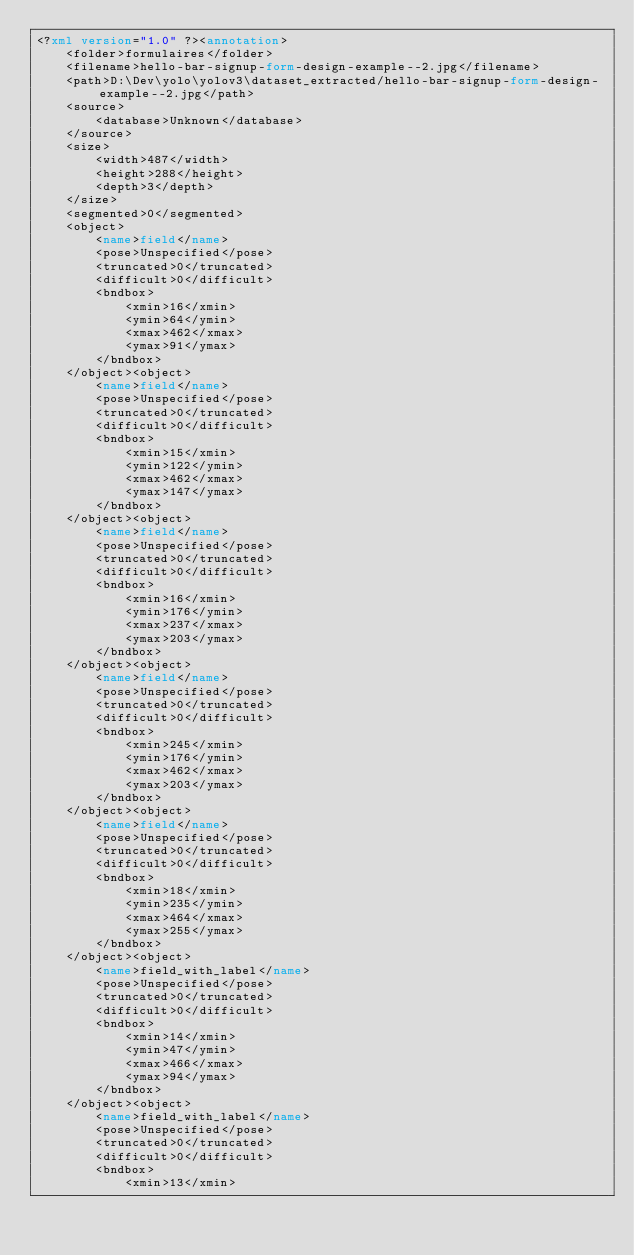<code> <loc_0><loc_0><loc_500><loc_500><_XML_><?xml version="1.0" ?><annotation>
    <folder>formulaires</folder>
    <filename>hello-bar-signup-form-design-example--2.jpg</filename>
    <path>D:\Dev\yolo\yolov3\dataset_extracted/hello-bar-signup-form-design-example--2.jpg</path>
    <source>
        <database>Unknown</database>
    </source>
    <size>
        <width>487</width>
        <height>288</height>
        <depth>3</depth>
    </size>
    <segmented>0</segmented>
    <object>
        <name>field</name>
        <pose>Unspecified</pose>
        <truncated>0</truncated>
        <difficult>0</difficult>
        <bndbox>
            <xmin>16</xmin>
            <ymin>64</ymin>
            <xmax>462</xmax>
            <ymax>91</ymax>
        </bndbox>
    </object><object>
        <name>field</name>
        <pose>Unspecified</pose>
        <truncated>0</truncated>
        <difficult>0</difficult>
        <bndbox>
            <xmin>15</xmin>
            <ymin>122</ymin>
            <xmax>462</xmax>
            <ymax>147</ymax>
        </bndbox>
    </object><object>
        <name>field</name>
        <pose>Unspecified</pose>
        <truncated>0</truncated>
        <difficult>0</difficult>
        <bndbox>
            <xmin>16</xmin>
            <ymin>176</ymin>
            <xmax>237</xmax>
            <ymax>203</ymax>
        </bndbox>
    </object><object>
        <name>field</name>
        <pose>Unspecified</pose>
        <truncated>0</truncated>
        <difficult>0</difficult>
        <bndbox>
            <xmin>245</xmin>
            <ymin>176</ymin>
            <xmax>462</xmax>
            <ymax>203</ymax>
        </bndbox>
    </object><object>
        <name>field</name>
        <pose>Unspecified</pose>
        <truncated>0</truncated>
        <difficult>0</difficult>
        <bndbox>
            <xmin>18</xmin>
            <ymin>235</ymin>
            <xmax>464</xmax>
            <ymax>255</ymax>
        </bndbox>
    </object><object>
        <name>field_with_label</name>
        <pose>Unspecified</pose>
        <truncated>0</truncated>
        <difficult>0</difficult>
        <bndbox>
            <xmin>14</xmin>
            <ymin>47</ymin>
            <xmax>466</xmax>
            <ymax>94</ymax>
        </bndbox>
    </object><object>
        <name>field_with_label</name>
        <pose>Unspecified</pose>
        <truncated>0</truncated>
        <difficult>0</difficult>
        <bndbox>
            <xmin>13</xmin></code> 